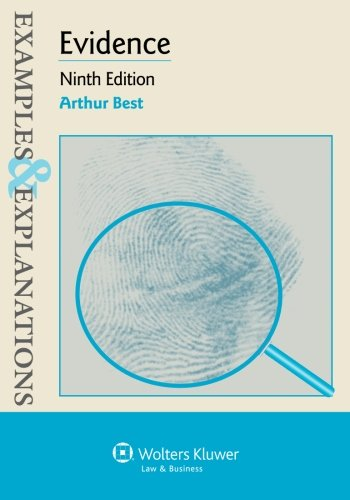What type of book is this? This book is a legal guide, specifically designed to assist students and professionals in understanding complex evidential law through practical examples and explanations. 